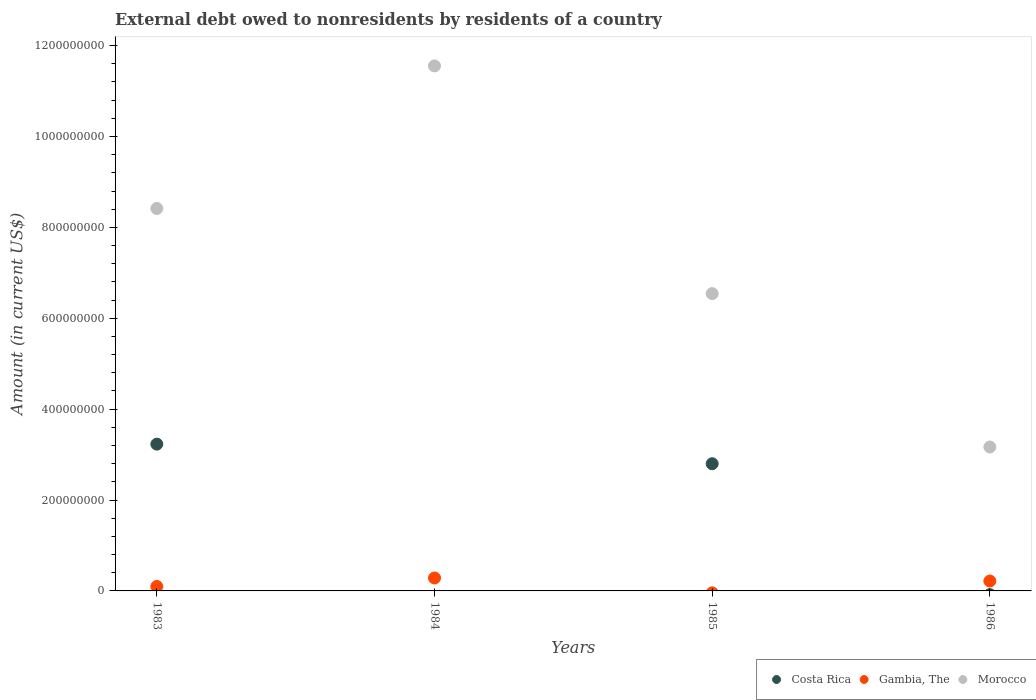How many different coloured dotlines are there?
Offer a terse response. 3. Across all years, what is the maximum external debt owed by residents in Gambia, The?
Keep it short and to the point. 2.85e+07. Across all years, what is the minimum external debt owed by residents in Morocco?
Keep it short and to the point. 3.17e+08. What is the total external debt owed by residents in Gambia, The in the graph?
Offer a very short reply. 6.01e+07. What is the difference between the external debt owed by residents in Morocco in 1985 and that in 1986?
Offer a very short reply. 3.38e+08. What is the difference between the external debt owed by residents in Morocco in 1984 and the external debt owed by residents in Gambia, The in 1983?
Offer a very short reply. 1.15e+09. What is the average external debt owed by residents in Morocco per year?
Keep it short and to the point. 7.42e+08. In the year 1985, what is the difference between the external debt owed by residents in Morocco and external debt owed by residents in Costa Rica?
Keep it short and to the point. 3.74e+08. In how many years, is the external debt owed by residents in Gambia, The greater than 240000000 US$?
Offer a very short reply. 0. What is the ratio of the external debt owed by residents in Gambia, The in 1984 to that in 1986?
Keep it short and to the point. 1.31. Is the difference between the external debt owed by residents in Morocco in 1983 and 1985 greater than the difference between the external debt owed by residents in Costa Rica in 1983 and 1985?
Keep it short and to the point. Yes. What is the difference between the highest and the lowest external debt owed by residents in Costa Rica?
Provide a short and direct response. 3.23e+08. In how many years, is the external debt owed by residents in Morocco greater than the average external debt owed by residents in Morocco taken over all years?
Provide a short and direct response. 2. Does the external debt owed by residents in Morocco monotonically increase over the years?
Keep it short and to the point. No. Is the external debt owed by residents in Morocco strictly greater than the external debt owed by residents in Costa Rica over the years?
Offer a terse response. Yes. Is the external debt owed by residents in Gambia, The strictly less than the external debt owed by residents in Costa Rica over the years?
Ensure brevity in your answer.  No. How many dotlines are there?
Keep it short and to the point. 3. Where does the legend appear in the graph?
Keep it short and to the point. Bottom right. What is the title of the graph?
Your response must be concise. External debt owed to nonresidents by residents of a country. What is the label or title of the X-axis?
Provide a succinct answer. Years. What is the label or title of the Y-axis?
Make the answer very short. Amount (in current US$). What is the Amount (in current US$) of Costa Rica in 1983?
Give a very brief answer. 3.23e+08. What is the Amount (in current US$) in Gambia, The in 1983?
Provide a succinct answer. 9.78e+06. What is the Amount (in current US$) in Morocco in 1983?
Ensure brevity in your answer.  8.42e+08. What is the Amount (in current US$) in Costa Rica in 1984?
Offer a terse response. 0. What is the Amount (in current US$) in Gambia, The in 1984?
Keep it short and to the point. 2.85e+07. What is the Amount (in current US$) of Morocco in 1984?
Ensure brevity in your answer.  1.16e+09. What is the Amount (in current US$) of Costa Rica in 1985?
Offer a very short reply. 2.80e+08. What is the Amount (in current US$) in Gambia, The in 1985?
Offer a terse response. 0. What is the Amount (in current US$) in Morocco in 1985?
Offer a very short reply. 6.54e+08. What is the Amount (in current US$) of Costa Rica in 1986?
Keep it short and to the point. 0. What is the Amount (in current US$) in Gambia, The in 1986?
Your answer should be compact. 2.18e+07. What is the Amount (in current US$) in Morocco in 1986?
Your answer should be compact. 3.17e+08. Across all years, what is the maximum Amount (in current US$) of Costa Rica?
Give a very brief answer. 3.23e+08. Across all years, what is the maximum Amount (in current US$) of Gambia, The?
Provide a succinct answer. 2.85e+07. Across all years, what is the maximum Amount (in current US$) of Morocco?
Your response must be concise. 1.16e+09. Across all years, what is the minimum Amount (in current US$) in Gambia, The?
Offer a terse response. 0. Across all years, what is the minimum Amount (in current US$) of Morocco?
Your response must be concise. 3.17e+08. What is the total Amount (in current US$) in Costa Rica in the graph?
Your answer should be very brief. 6.03e+08. What is the total Amount (in current US$) of Gambia, The in the graph?
Offer a terse response. 6.01e+07. What is the total Amount (in current US$) in Morocco in the graph?
Provide a short and direct response. 2.97e+09. What is the difference between the Amount (in current US$) in Gambia, The in 1983 and that in 1984?
Your answer should be very brief. -1.87e+07. What is the difference between the Amount (in current US$) of Morocco in 1983 and that in 1984?
Your answer should be very brief. -3.14e+08. What is the difference between the Amount (in current US$) of Costa Rica in 1983 and that in 1985?
Your answer should be compact. 4.31e+07. What is the difference between the Amount (in current US$) in Morocco in 1983 and that in 1985?
Keep it short and to the point. 1.87e+08. What is the difference between the Amount (in current US$) of Gambia, The in 1983 and that in 1986?
Make the answer very short. -1.20e+07. What is the difference between the Amount (in current US$) of Morocco in 1983 and that in 1986?
Offer a terse response. 5.25e+08. What is the difference between the Amount (in current US$) of Morocco in 1984 and that in 1985?
Offer a very short reply. 5.01e+08. What is the difference between the Amount (in current US$) in Gambia, The in 1984 and that in 1986?
Ensure brevity in your answer.  6.68e+06. What is the difference between the Amount (in current US$) in Morocco in 1984 and that in 1986?
Keep it short and to the point. 8.39e+08. What is the difference between the Amount (in current US$) in Morocco in 1985 and that in 1986?
Offer a terse response. 3.38e+08. What is the difference between the Amount (in current US$) of Costa Rica in 1983 and the Amount (in current US$) of Gambia, The in 1984?
Keep it short and to the point. 2.95e+08. What is the difference between the Amount (in current US$) in Costa Rica in 1983 and the Amount (in current US$) in Morocco in 1984?
Provide a short and direct response. -8.32e+08. What is the difference between the Amount (in current US$) in Gambia, The in 1983 and the Amount (in current US$) in Morocco in 1984?
Give a very brief answer. -1.15e+09. What is the difference between the Amount (in current US$) of Costa Rica in 1983 and the Amount (in current US$) of Morocco in 1985?
Your answer should be very brief. -3.31e+08. What is the difference between the Amount (in current US$) in Gambia, The in 1983 and the Amount (in current US$) in Morocco in 1985?
Provide a short and direct response. -6.44e+08. What is the difference between the Amount (in current US$) of Costa Rica in 1983 and the Amount (in current US$) of Gambia, The in 1986?
Make the answer very short. 3.01e+08. What is the difference between the Amount (in current US$) in Costa Rica in 1983 and the Amount (in current US$) in Morocco in 1986?
Ensure brevity in your answer.  6.30e+06. What is the difference between the Amount (in current US$) of Gambia, The in 1983 and the Amount (in current US$) of Morocco in 1986?
Ensure brevity in your answer.  -3.07e+08. What is the difference between the Amount (in current US$) of Gambia, The in 1984 and the Amount (in current US$) of Morocco in 1985?
Offer a very short reply. -6.26e+08. What is the difference between the Amount (in current US$) of Gambia, The in 1984 and the Amount (in current US$) of Morocco in 1986?
Your answer should be compact. -2.88e+08. What is the difference between the Amount (in current US$) in Costa Rica in 1985 and the Amount (in current US$) in Gambia, The in 1986?
Your answer should be very brief. 2.58e+08. What is the difference between the Amount (in current US$) of Costa Rica in 1985 and the Amount (in current US$) of Morocco in 1986?
Keep it short and to the point. -3.68e+07. What is the average Amount (in current US$) in Costa Rica per year?
Provide a short and direct response. 1.51e+08. What is the average Amount (in current US$) in Gambia, The per year?
Provide a succinct answer. 1.50e+07. What is the average Amount (in current US$) in Morocco per year?
Offer a very short reply. 7.42e+08. In the year 1983, what is the difference between the Amount (in current US$) of Costa Rica and Amount (in current US$) of Gambia, The?
Your answer should be compact. 3.13e+08. In the year 1983, what is the difference between the Amount (in current US$) of Costa Rica and Amount (in current US$) of Morocco?
Provide a succinct answer. -5.19e+08. In the year 1983, what is the difference between the Amount (in current US$) in Gambia, The and Amount (in current US$) in Morocco?
Your answer should be compact. -8.32e+08. In the year 1984, what is the difference between the Amount (in current US$) in Gambia, The and Amount (in current US$) in Morocco?
Your response must be concise. -1.13e+09. In the year 1985, what is the difference between the Amount (in current US$) in Costa Rica and Amount (in current US$) in Morocco?
Provide a short and direct response. -3.74e+08. In the year 1986, what is the difference between the Amount (in current US$) in Gambia, The and Amount (in current US$) in Morocco?
Your response must be concise. -2.95e+08. What is the ratio of the Amount (in current US$) of Gambia, The in 1983 to that in 1984?
Offer a very short reply. 0.34. What is the ratio of the Amount (in current US$) of Morocco in 1983 to that in 1984?
Your answer should be very brief. 0.73. What is the ratio of the Amount (in current US$) of Costa Rica in 1983 to that in 1985?
Provide a succinct answer. 1.15. What is the ratio of the Amount (in current US$) of Morocco in 1983 to that in 1985?
Offer a very short reply. 1.29. What is the ratio of the Amount (in current US$) in Gambia, The in 1983 to that in 1986?
Ensure brevity in your answer.  0.45. What is the ratio of the Amount (in current US$) of Morocco in 1983 to that in 1986?
Keep it short and to the point. 2.66. What is the ratio of the Amount (in current US$) in Morocco in 1984 to that in 1985?
Provide a short and direct response. 1.77. What is the ratio of the Amount (in current US$) of Gambia, The in 1984 to that in 1986?
Provide a succinct answer. 1.31. What is the ratio of the Amount (in current US$) in Morocco in 1984 to that in 1986?
Offer a very short reply. 3.65. What is the ratio of the Amount (in current US$) of Morocco in 1985 to that in 1986?
Give a very brief answer. 2.07. What is the difference between the highest and the second highest Amount (in current US$) of Gambia, The?
Offer a very short reply. 6.68e+06. What is the difference between the highest and the second highest Amount (in current US$) of Morocco?
Your answer should be very brief. 3.14e+08. What is the difference between the highest and the lowest Amount (in current US$) of Costa Rica?
Your answer should be very brief. 3.23e+08. What is the difference between the highest and the lowest Amount (in current US$) of Gambia, The?
Keep it short and to the point. 2.85e+07. What is the difference between the highest and the lowest Amount (in current US$) in Morocco?
Provide a succinct answer. 8.39e+08. 